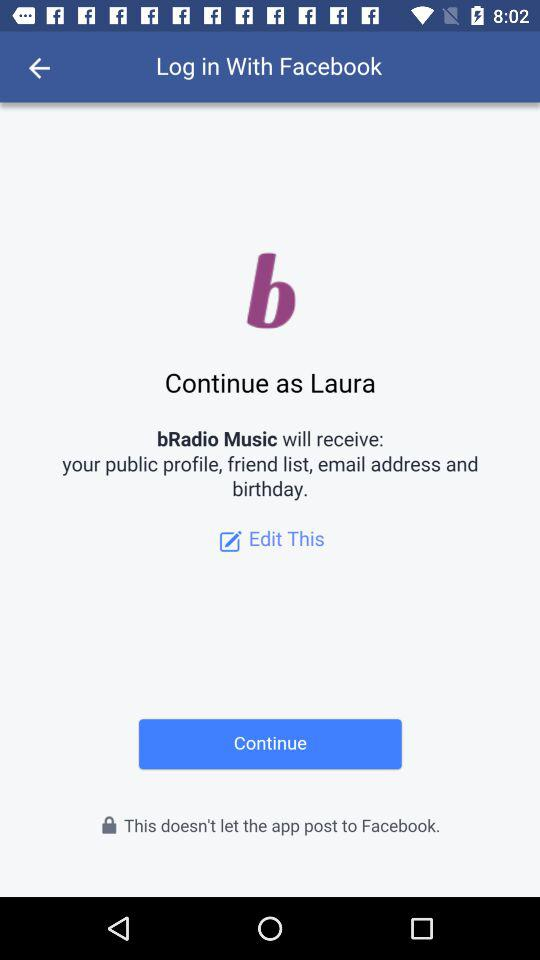What is the app name? The app name is "Facebook". 